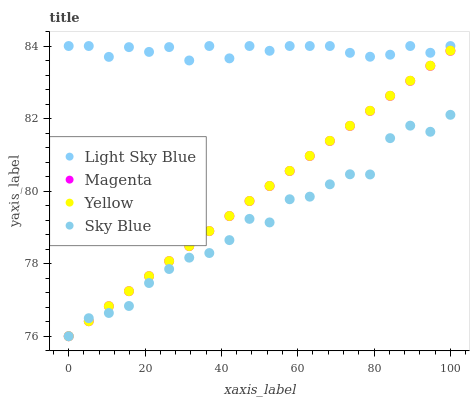Does Sky Blue have the minimum area under the curve?
Answer yes or no. Yes. Does Light Sky Blue have the maximum area under the curve?
Answer yes or no. Yes. Does Magenta have the minimum area under the curve?
Answer yes or no. No. Does Magenta have the maximum area under the curve?
Answer yes or no. No. Is Yellow the smoothest?
Answer yes or no. Yes. Is Sky Blue the roughest?
Answer yes or no. Yes. Is Magenta the smoothest?
Answer yes or no. No. Is Magenta the roughest?
Answer yes or no. No. Does Sky Blue have the lowest value?
Answer yes or no. Yes. Does Light Sky Blue have the lowest value?
Answer yes or no. No. Does Light Sky Blue have the highest value?
Answer yes or no. Yes. Does Magenta have the highest value?
Answer yes or no. No. Is Magenta less than Light Sky Blue?
Answer yes or no. Yes. Is Light Sky Blue greater than Magenta?
Answer yes or no. Yes. Does Magenta intersect Yellow?
Answer yes or no. Yes. Is Magenta less than Yellow?
Answer yes or no. No. Is Magenta greater than Yellow?
Answer yes or no. No. Does Magenta intersect Light Sky Blue?
Answer yes or no. No. 